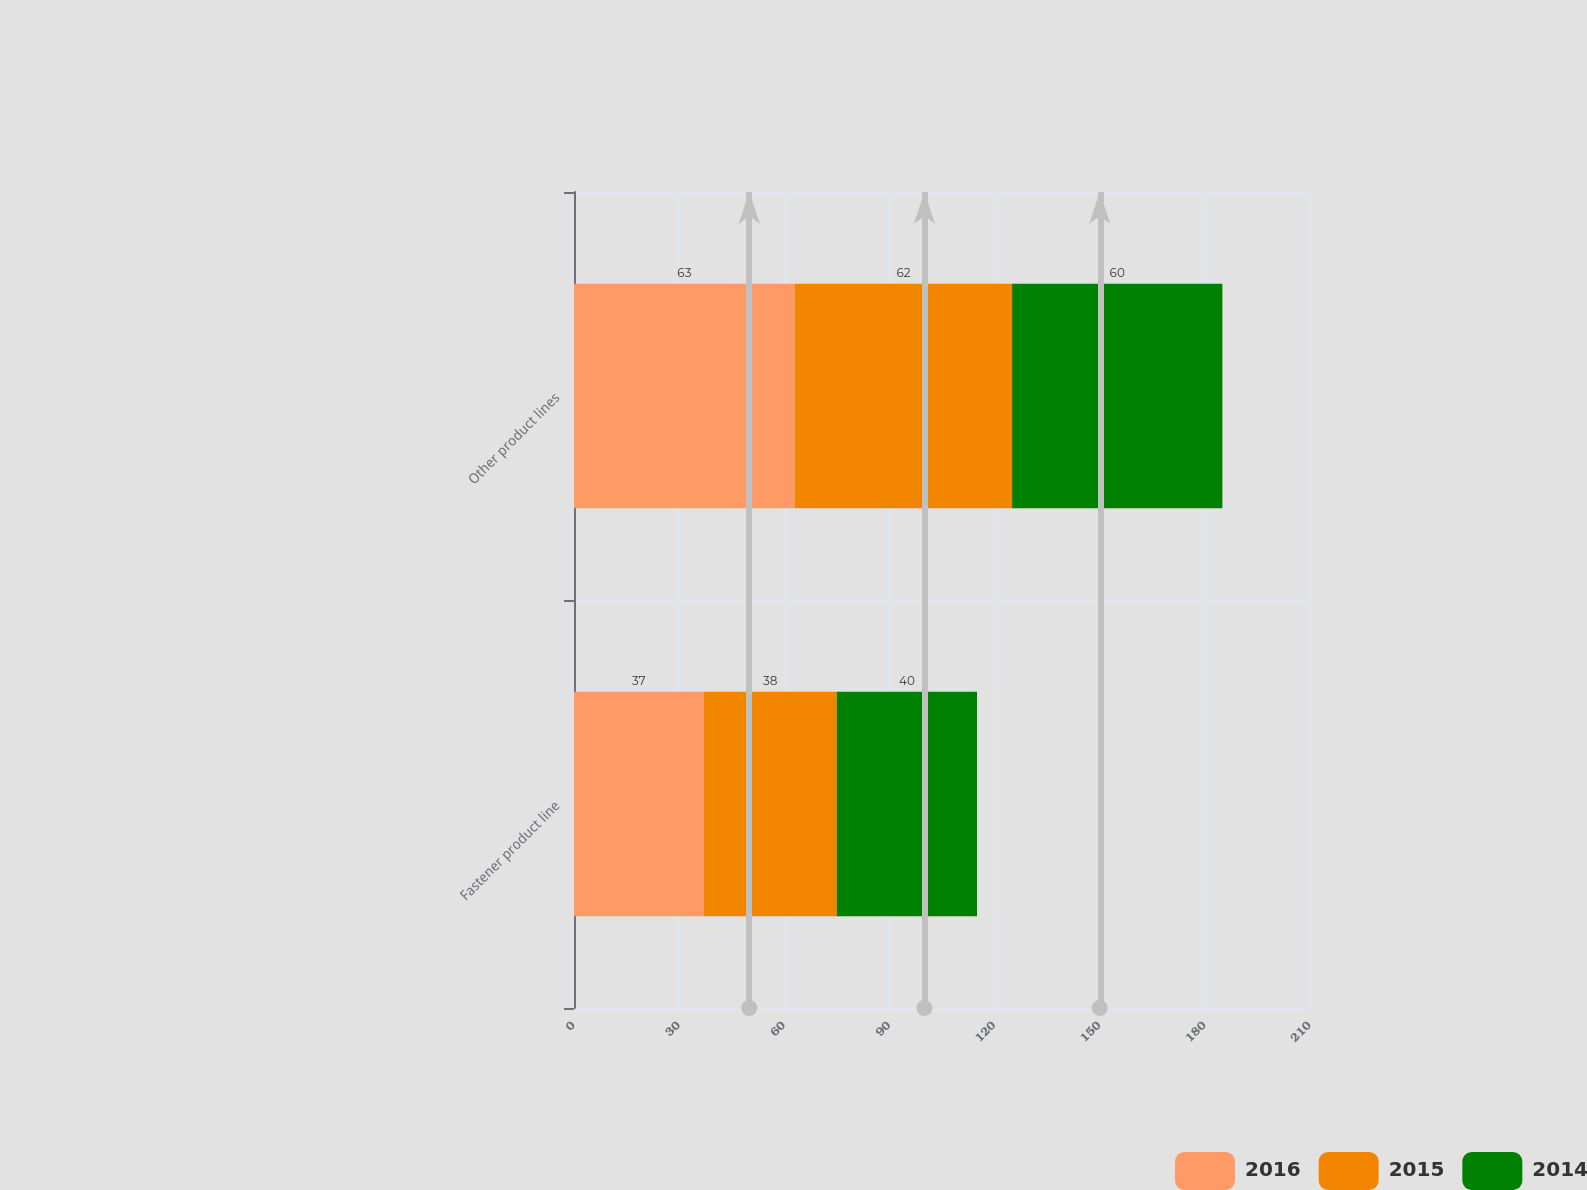Convert chart. <chart><loc_0><loc_0><loc_500><loc_500><stacked_bar_chart><ecel><fcel>Fastener product line<fcel>Other product lines<nl><fcel>2016<fcel>37<fcel>63<nl><fcel>2015<fcel>38<fcel>62<nl><fcel>2014<fcel>40<fcel>60<nl></chart> 